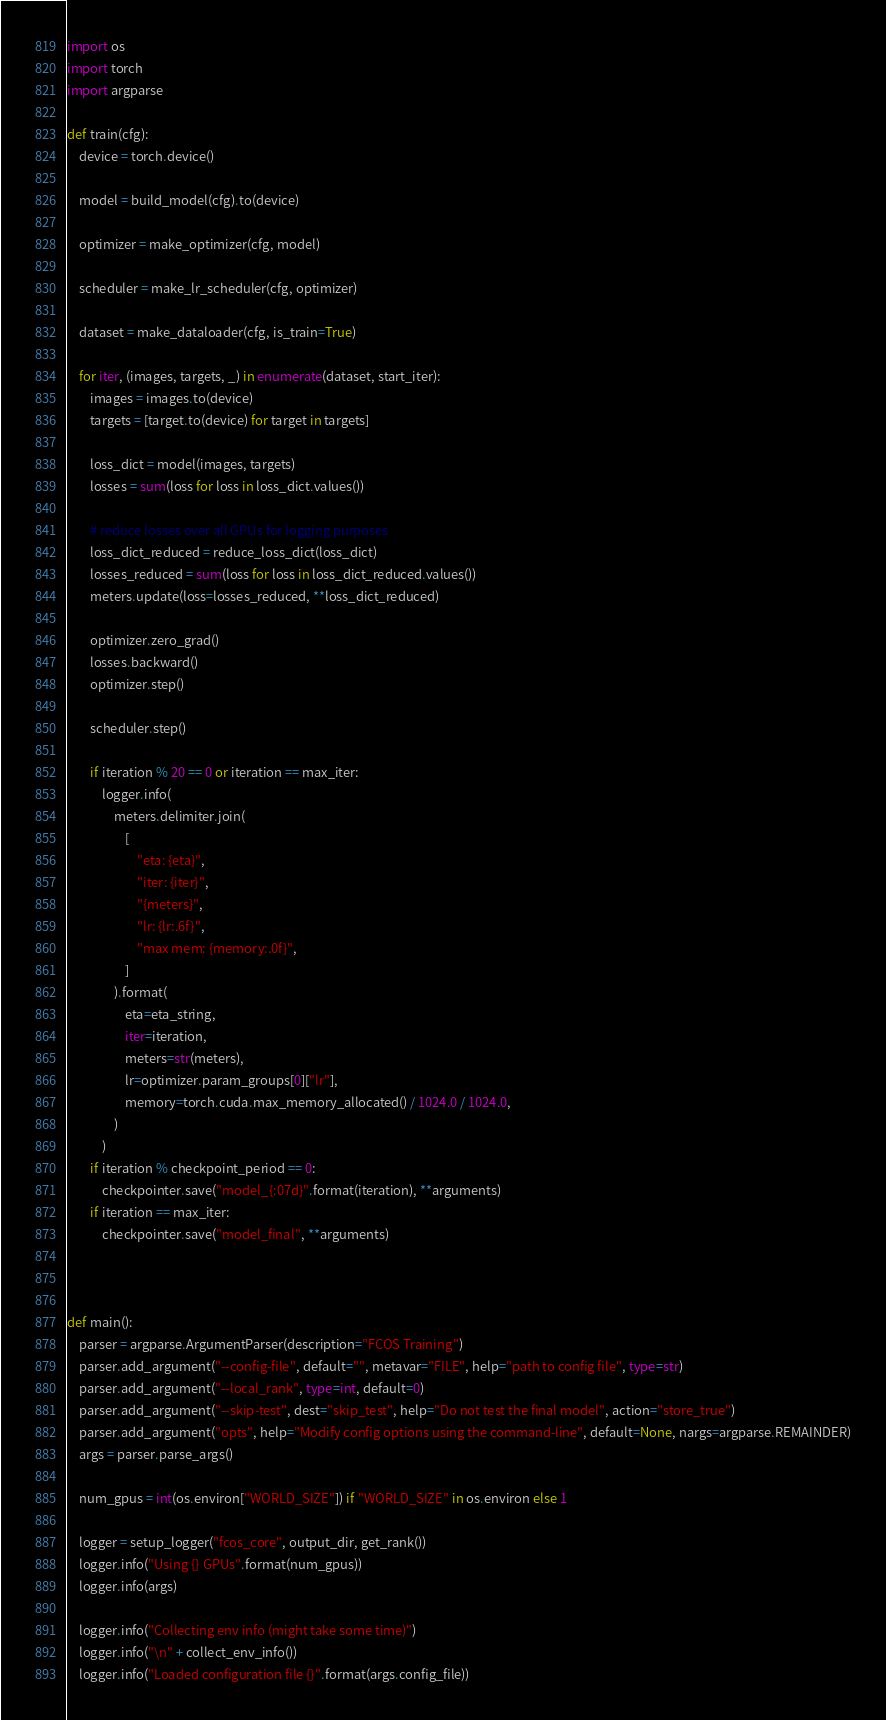<code> <loc_0><loc_0><loc_500><loc_500><_Python_>
import os
import torch
import argparse

def train(cfg):
    device = torch.device()

    model = build_model(cfg).to(device)

    optimizer = make_optimizer(cfg, model)

    scheduler = make_lr_scheduler(cfg, optimizer)

    dataset = make_dataloader(cfg, is_train=True)

    for iter, (images, targets, _) in enumerate(dataset, start_iter):
        images = images.to(device)
        targets = [target.to(device) for target in targets]

        loss_dict = model(images, targets)
        losses = sum(loss for loss in loss_dict.values())

        # reduce losses over all GPUs for logging purposes
        loss_dict_reduced = reduce_loss_dict(loss_dict)
        losses_reduced = sum(loss for loss in loss_dict_reduced.values())
        meters.update(loss=losses_reduced, **loss_dict_reduced)

        optimizer.zero_grad()
        losses.backward()
        optimizer.step()

        scheduler.step()

        if iteration % 20 == 0 or iteration == max_iter:
            logger.info(
                meters.delimiter.join(
                    [
                        "eta: {eta}",
                        "iter: {iter}",
                        "{meters}",
                        "lr: {lr:.6f}",
                        "max mem: {memory:.0f}",
                    ]
                ).format(
                    eta=eta_string,
                    iter=iteration,
                    meters=str(meters),
                    lr=optimizer.param_groups[0]["lr"],
                    memory=torch.cuda.max_memory_allocated() / 1024.0 / 1024.0,
                )
            )
        if iteration % checkpoint_period == 0:
            checkpointer.save("model_{:07d}".format(iteration), **arguments)
        if iteration == max_iter:
            checkpointer.save("model_final", **arguments)



def main():
    parser = argparse.ArgumentParser(description="FCOS Training")
    parser.add_argument("--config-file", default="", metavar="FILE", help="path to config file", type=str)
    parser.add_argument("--local_rank", type=int, default=0)
    parser.add_argument("--skip-test", dest="skip_test", help="Do not test the final model", action="store_true")
    parser.add_argument("opts", help="Modify config options using the command-line", default=None, nargs=argparse.REMAINDER)
    args = parser.parse_args()

    num_gpus = int(os.environ["WORLD_SIZE"]) if "WORLD_SIZE" in os.environ else 1

    logger = setup_logger("fcos_core", output_dir, get_rank())
    logger.info("Using {} GPUs".format(num_gpus))
    logger.info(args)

    logger.info("Collecting env info (might take some time)")
    logger.info("\n" + collect_env_info())
    logger.info("Loaded configuration file {}".format(args.config_file))

</code> 